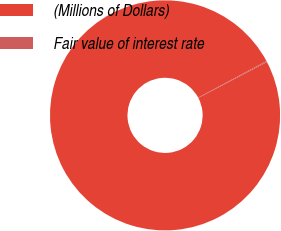Convert chart. <chart><loc_0><loc_0><loc_500><loc_500><pie_chart><fcel>(Millions of Dollars)<fcel>Fair value of interest rate<nl><fcel>99.85%<fcel>0.15%<nl></chart> 